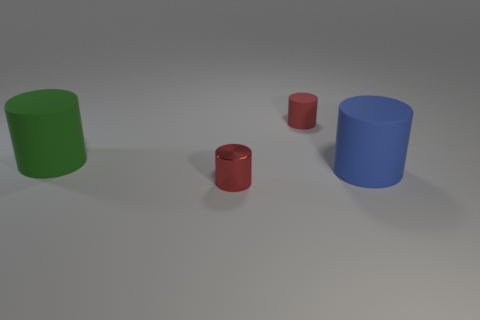There is a big thing that is made of the same material as the large blue cylinder; what color is it?
Offer a terse response. Green. Do the red object behind the red shiny object and the large green matte cylinder have the same size?
Ensure brevity in your answer.  No. What number of things are large matte cylinders or red metal objects?
Provide a short and direct response. 3. There is a red object to the right of the red cylinder that is to the left of the red rubber cylinder to the left of the big blue rubber object; what is its material?
Your answer should be compact. Rubber. What material is the small object that is behind the tiny red metal cylinder?
Your response must be concise. Rubber. Is there a red metal cylinder of the same size as the green rubber cylinder?
Ensure brevity in your answer.  No. Does the large thing that is on the right side of the red matte thing have the same color as the small matte cylinder?
Your answer should be very brief. No. How many red objects are either small shiny cylinders or large matte things?
Provide a succinct answer. 1. How many rubber cylinders have the same color as the tiny shiny thing?
Offer a very short reply. 1. Is the large green object made of the same material as the blue cylinder?
Provide a short and direct response. Yes. 